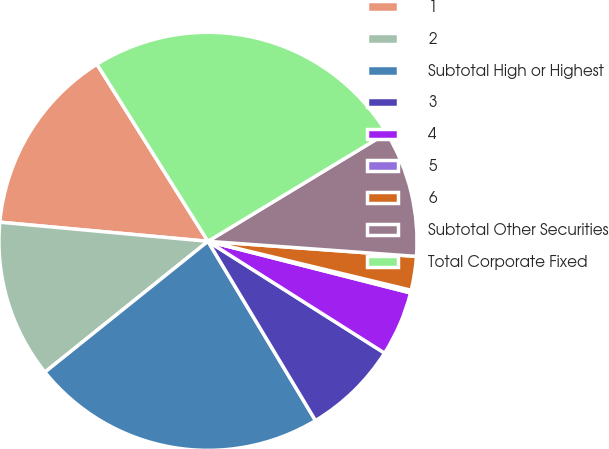Convert chart to OTSL. <chart><loc_0><loc_0><loc_500><loc_500><pie_chart><fcel>1<fcel>2<fcel>Subtotal High or Highest<fcel>3<fcel>4<fcel>5<fcel>6<fcel>Subtotal Other Securities<fcel>Total Corporate Fixed<nl><fcel>14.63%<fcel>12.22%<fcel>22.84%<fcel>7.42%<fcel>5.01%<fcel>0.21%<fcel>2.61%<fcel>9.82%<fcel>25.24%<nl></chart> 